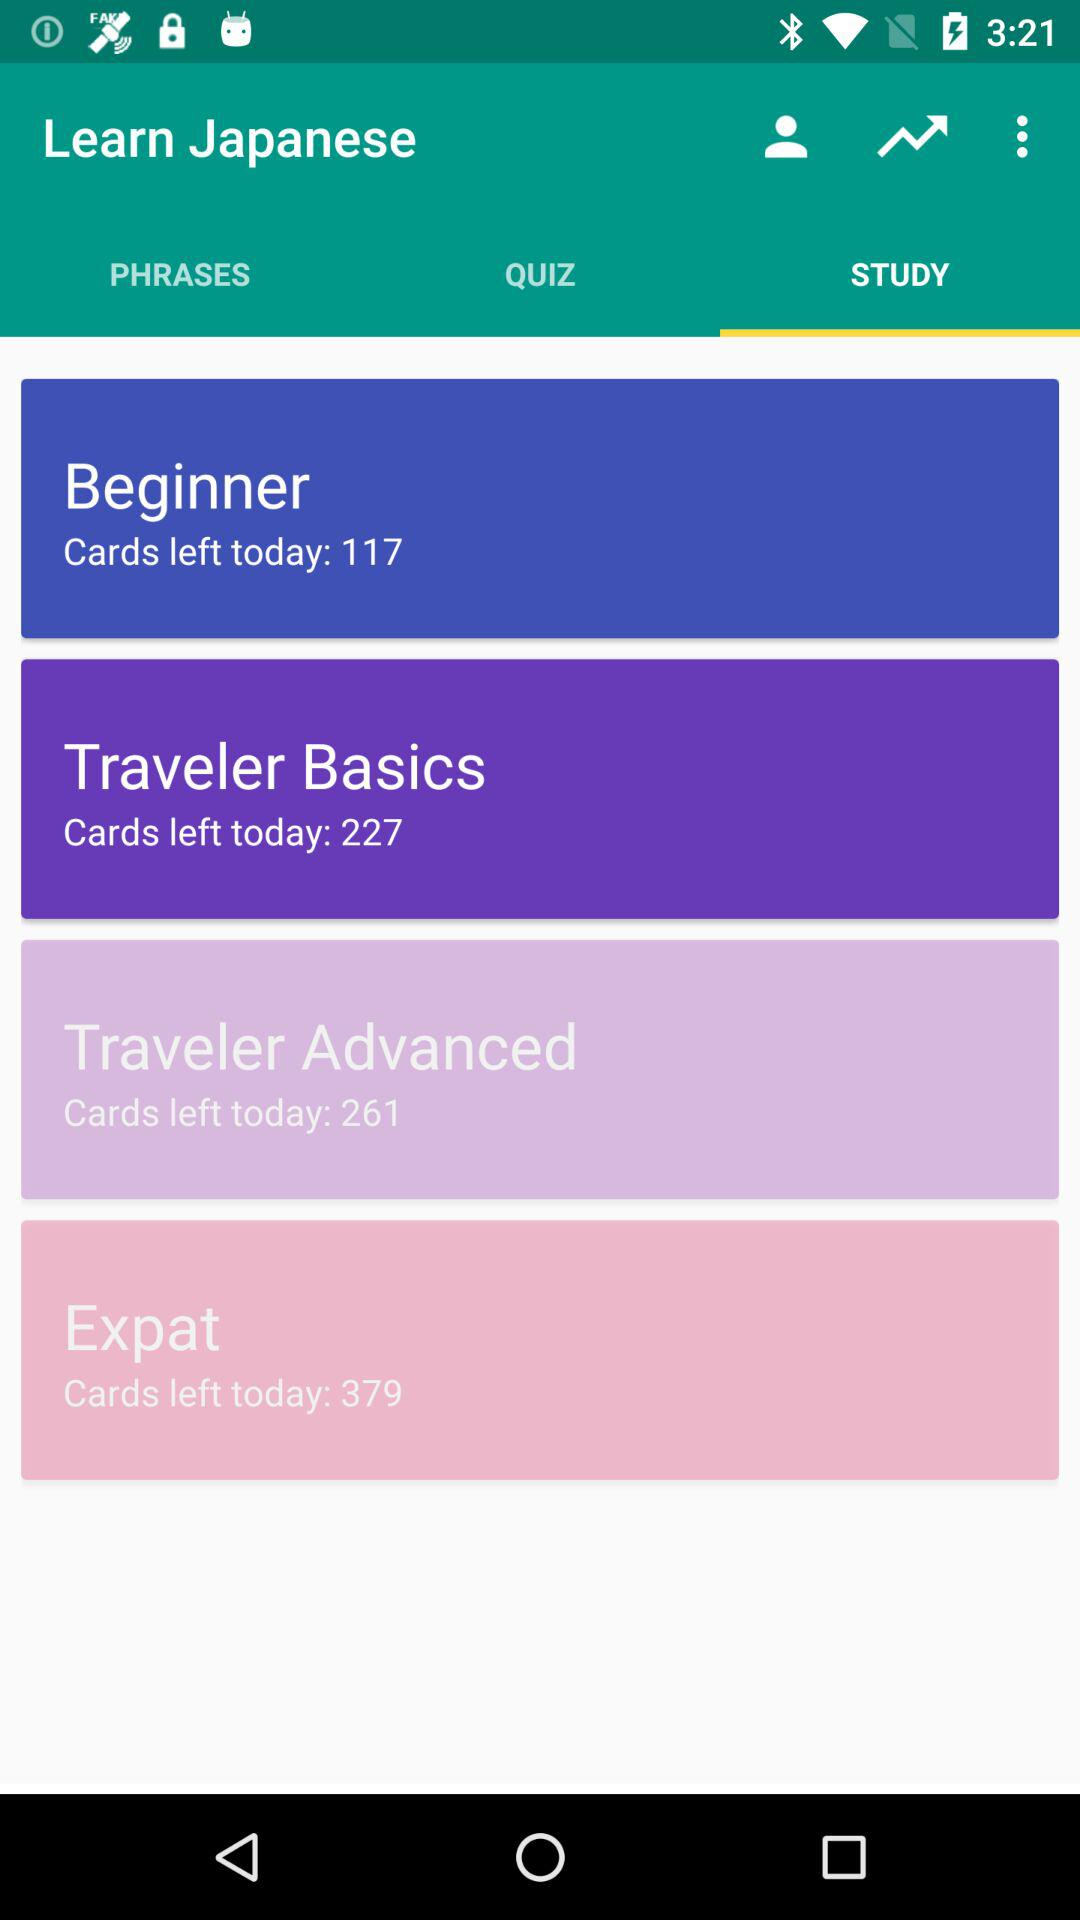How many more cards are left for the Traveler Advanced level than the Beginner level?
Answer the question using a single word or phrase. 144 